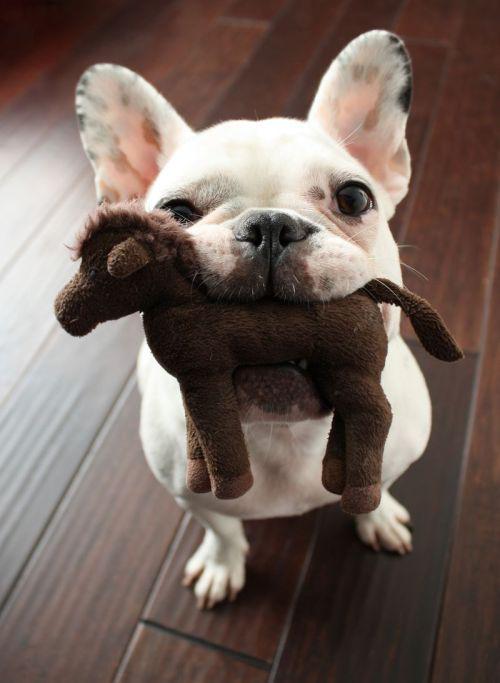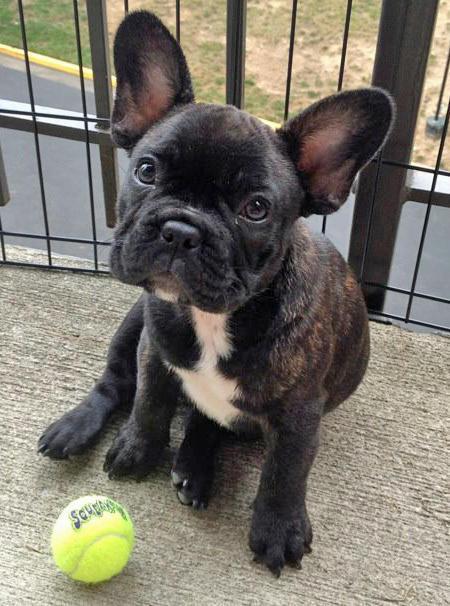The first image is the image on the left, the second image is the image on the right. Evaluate the accuracy of this statement regarding the images: "There are exactly three puppies.". Is it true? Answer yes or no. No. The first image is the image on the left, the second image is the image on the right. Considering the images on both sides, is "One of the dogs is biting a stuffed animal." valid? Answer yes or no. Yes. The first image is the image on the left, the second image is the image on the right. Given the left and right images, does the statement "In one of the image the dog is on the grass." hold true? Answer yes or no. No. The first image is the image on the left, the second image is the image on the right. Analyze the images presented: Is the assertion "There are three dogs" valid? Answer yes or no. No. 